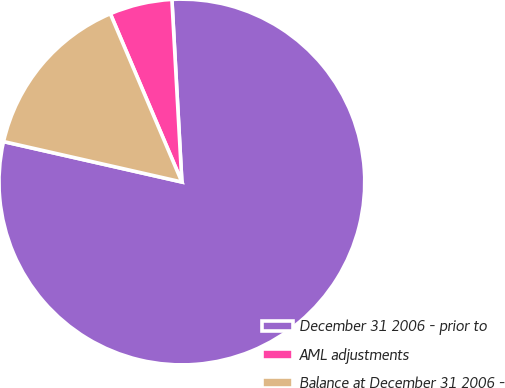Convert chart to OTSL. <chart><loc_0><loc_0><loc_500><loc_500><pie_chart><fcel>December 31 2006 - prior to<fcel>AML adjustments<fcel>Balance at December 31 2006 -<nl><fcel>79.42%<fcel>5.53%<fcel>15.05%<nl></chart> 